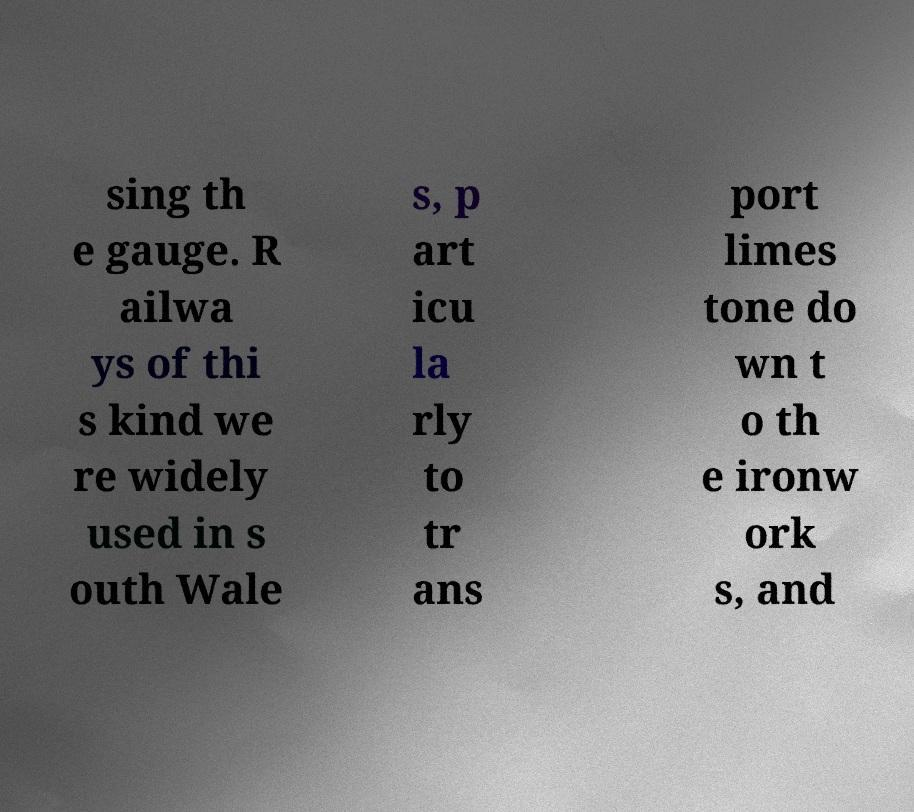Could you assist in decoding the text presented in this image and type it out clearly? sing th e gauge. R ailwa ys of thi s kind we re widely used in s outh Wale s, p art icu la rly to tr ans port limes tone do wn t o th e ironw ork s, and 